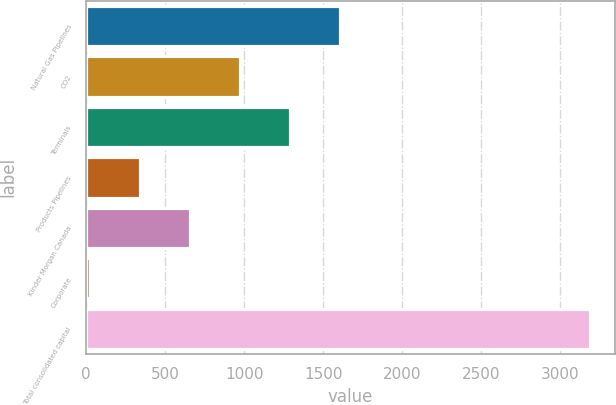<chart> <loc_0><loc_0><loc_500><loc_500><bar_chart><fcel>Natural Gas Pipelines<fcel>CO2<fcel>Terminals<fcel>Products Pipelines<fcel>Kinder Morgan Canada<fcel>Corporate<fcel>Total consolidated capital<nl><fcel>1605.5<fcel>972.5<fcel>1289<fcel>339.5<fcel>656<fcel>23<fcel>3188<nl></chart> 